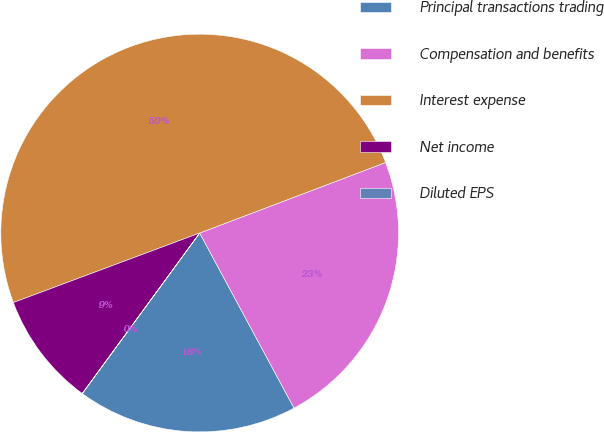Convert chart. <chart><loc_0><loc_0><loc_500><loc_500><pie_chart><fcel>Principal transactions trading<fcel>Compensation and benefits<fcel>Interest expense<fcel>Net income<fcel>Diluted EPS<nl><fcel>17.91%<fcel>22.9%<fcel>49.91%<fcel>9.26%<fcel>0.01%<nl></chart> 